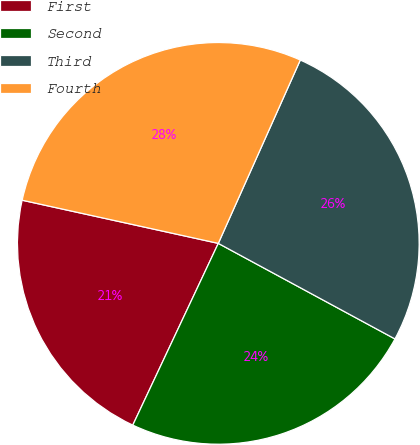Convert chart to OTSL. <chart><loc_0><loc_0><loc_500><loc_500><pie_chart><fcel>First<fcel>Second<fcel>Third<fcel>Fourth<nl><fcel>21.45%<fcel>24.11%<fcel>26.2%<fcel>28.25%<nl></chart> 